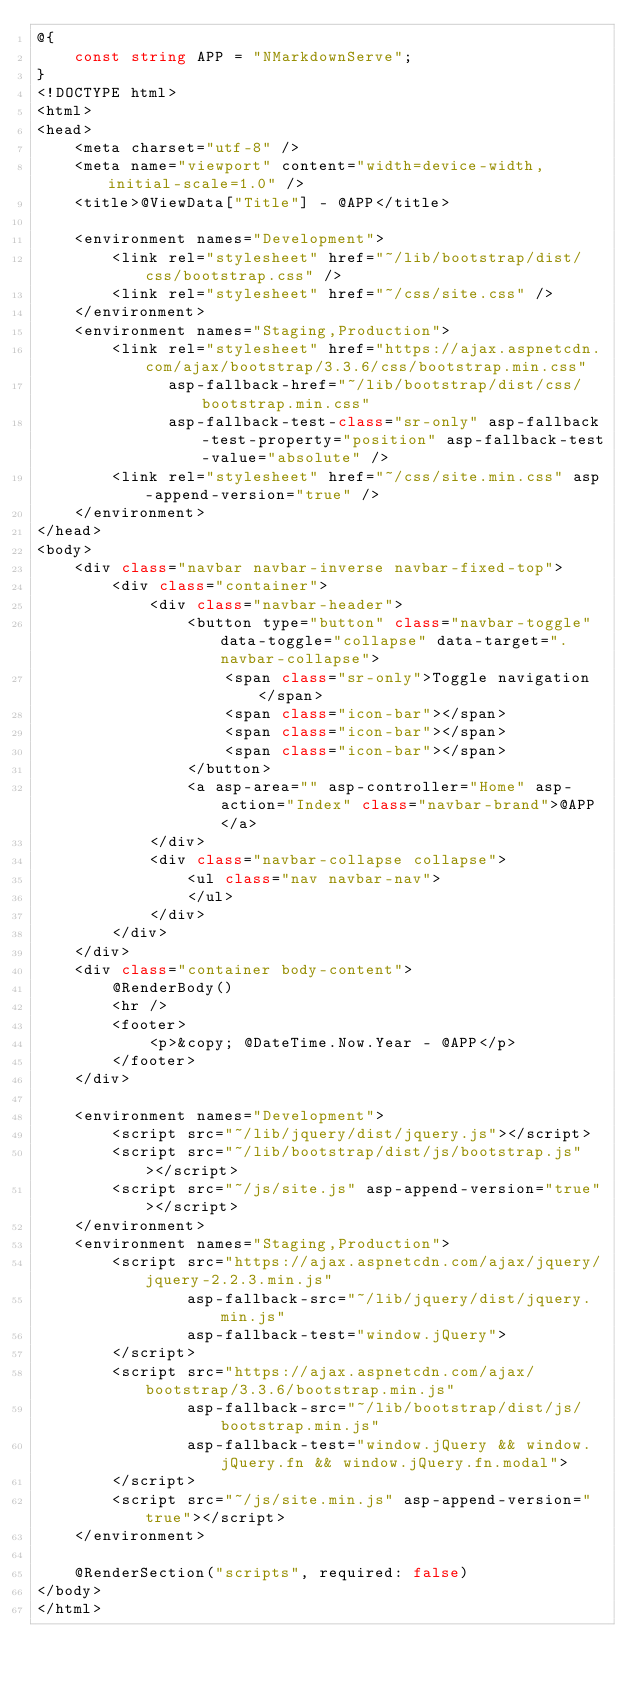<code> <loc_0><loc_0><loc_500><loc_500><_C#_>@{
    const string APP = "NMarkdownServe";
}
<!DOCTYPE html>
<html>
<head>
    <meta charset="utf-8" />
    <meta name="viewport" content="width=device-width, initial-scale=1.0" />
    <title>@ViewData["Title"] - @APP</title>

    <environment names="Development">
        <link rel="stylesheet" href="~/lib/bootstrap/dist/css/bootstrap.css" />
        <link rel="stylesheet" href="~/css/site.css" />
    </environment>
    <environment names="Staging,Production">
        <link rel="stylesheet" href="https://ajax.aspnetcdn.com/ajax/bootstrap/3.3.6/css/bootstrap.min.css"
              asp-fallback-href="~/lib/bootstrap/dist/css/bootstrap.min.css"
              asp-fallback-test-class="sr-only" asp-fallback-test-property="position" asp-fallback-test-value="absolute" />
        <link rel="stylesheet" href="~/css/site.min.css" asp-append-version="true" />
    </environment>
</head>
<body>
    <div class="navbar navbar-inverse navbar-fixed-top">
        <div class="container">
            <div class="navbar-header">
                <button type="button" class="navbar-toggle" data-toggle="collapse" data-target=".navbar-collapse">
                    <span class="sr-only">Toggle navigation</span>
                    <span class="icon-bar"></span>
                    <span class="icon-bar"></span>
                    <span class="icon-bar"></span>
                </button>
                <a asp-area="" asp-controller="Home" asp-action="Index" class="navbar-brand">@APP</a>
            </div>
            <div class="navbar-collapse collapse">
                <ul class="nav navbar-nav">
                </ul>
            </div>
        </div>
    </div>
    <div class="container body-content">
        @RenderBody()
        <hr />
        <footer>
            <p>&copy; @DateTime.Now.Year - @APP</p>
        </footer>
    </div>

    <environment names="Development">
        <script src="~/lib/jquery/dist/jquery.js"></script>
        <script src="~/lib/bootstrap/dist/js/bootstrap.js"></script>
        <script src="~/js/site.js" asp-append-version="true"></script>
    </environment>
    <environment names="Staging,Production">
        <script src="https://ajax.aspnetcdn.com/ajax/jquery/jquery-2.2.3.min.js"
                asp-fallback-src="~/lib/jquery/dist/jquery.min.js"
                asp-fallback-test="window.jQuery">
        </script>
        <script src="https://ajax.aspnetcdn.com/ajax/bootstrap/3.3.6/bootstrap.min.js"
                asp-fallback-src="~/lib/bootstrap/dist/js/bootstrap.min.js"
                asp-fallback-test="window.jQuery && window.jQuery.fn && window.jQuery.fn.modal">
        </script>
        <script src="~/js/site.min.js" asp-append-version="true"></script>
    </environment>

    @RenderSection("scripts", required: false)
</body>
</html>
</code> 